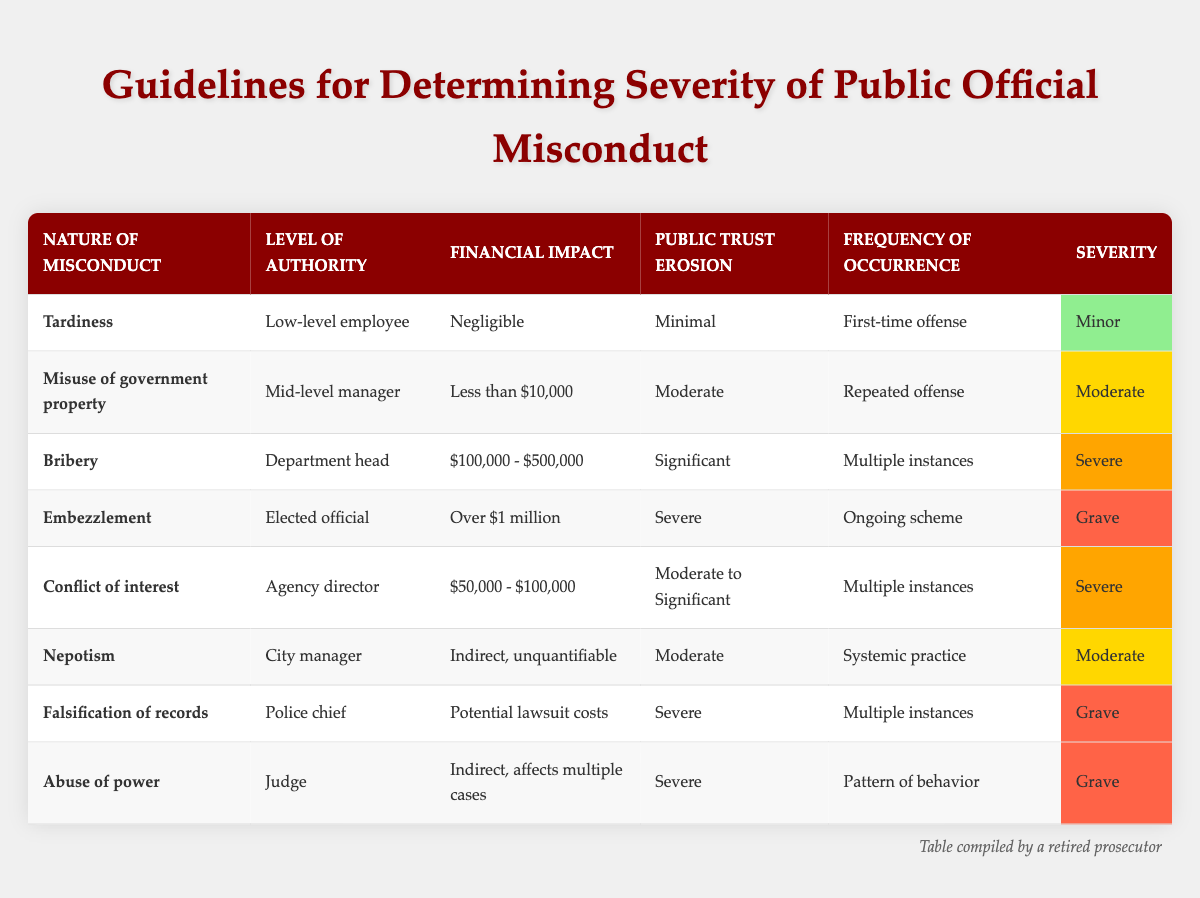What is the severity of the misconduct "Tardiness"? The table lists "Tardiness" under the column "Severity," which shows that its severity level is "Minor."
Answer: Minor How many misconduct cases have a financial impact of over $1 million? By examining the table, only one case, "Embezzlement," fits this criteria with a financial impact categorized as "Over $1 million."
Answer: 1 Is the public trust erosion for "Abuse of power" significant? The "Public Trust Erosion" column for "Abuse of power" indicates "Severe," which qualifies as significant.
Answer: Yes What are the two misconduct types with severe severity? Scanning the table reveals that "Bribery" and "Conflict of interest" are both marked with the severity level of "Severe."
Answer: Bribery, Conflict of interest Which misconduct type has the highest level of authority? The misconduct "Embezzlement" is categorized under "Elected official," which is ranked the highest in the authority hierarchy among the listed cases.
Answer: Elected official How many times is "Misuse of government property" listed as a repeated offense? The table specifies that "Misuse of government property" is classified under the "Frequency of Occurrence" as "Repeated offense" only once.
Answer: 1 What is the average financial impact of misconduct types listed as "Moderate"? The table shows two cases with "Moderate" financial impact: "Misuse of government property" (less than $10,000) and "Nepotism" (Indirect, unquantifiable). As it cannot be quantified, we consider only the case with a specific amount, therefore, the average cannot be calculated and remains undefined.
Answer: Undefined Which misconduct type occurs multiple times and has significant public trust erosion? In the table, "Falsification of records" and "Bribery" both occur multiple times with "Severe" public trust erosion, hence confirming they fit this description.
Answer: Falsification of records, Bribery Are there any cases where financial impact is categorized as "Negligible"? The table features one case, "Tardiness," that distinctly marks its financial impact as "Negligible."
Answer: Yes 